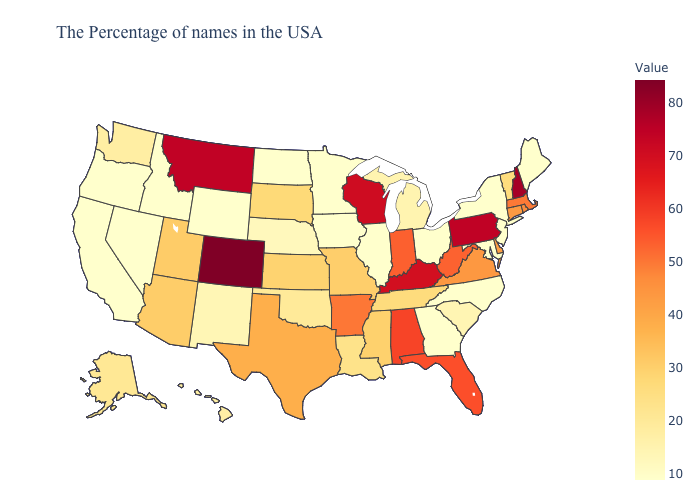Which states have the lowest value in the USA?
Concise answer only. Maine, New York, Maryland, North Carolina, Ohio, Georgia, Illinois, Minnesota, Iowa, North Dakota, Wyoming, Idaho, Nevada, California, Oregon. Does Nebraska have the highest value in the USA?
Write a very short answer. No. Which states have the lowest value in the USA?
Give a very brief answer. Maine, New York, Maryland, North Carolina, Ohio, Georgia, Illinois, Minnesota, Iowa, North Dakota, Wyoming, Idaho, Nevada, California, Oregon. Which states hav the highest value in the South?
Keep it brief. Kentucky. Which states hav the highest value in the South?
Answer briefly. Kentucky. Which states have the highest value in the USA?
Answer briefly. Colorado. Among the states that border New York , which have the highest value?
Give a very brief answer. Pennsylvania. 